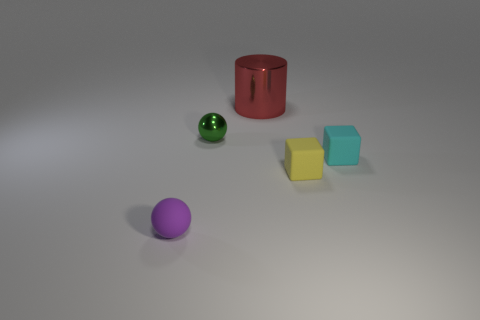Subtract all balls. How many objects are left? 3 Add 2 matte objects. How many objects exist? 7 Subtract 1 cyan cubes. How many objects are left? 4 Subtract 1 cylinders. How many cylinders are left? 0 Subtract all blue balls. Subtract all yellow blocks. How many balls are left? 2 Subtract all blue balls. How many brown cylinders are left? 0 Subtract all small yellow cubes. Subtract all red cylinders. How many objects are left? 3 Add 5 small yellow rubber objects. How many small yellow rubber objects are left? 6 Add 5 big blue cubes. How many big blue cubes exist? 5 Subtract all green balls. How many balls are left? 1 